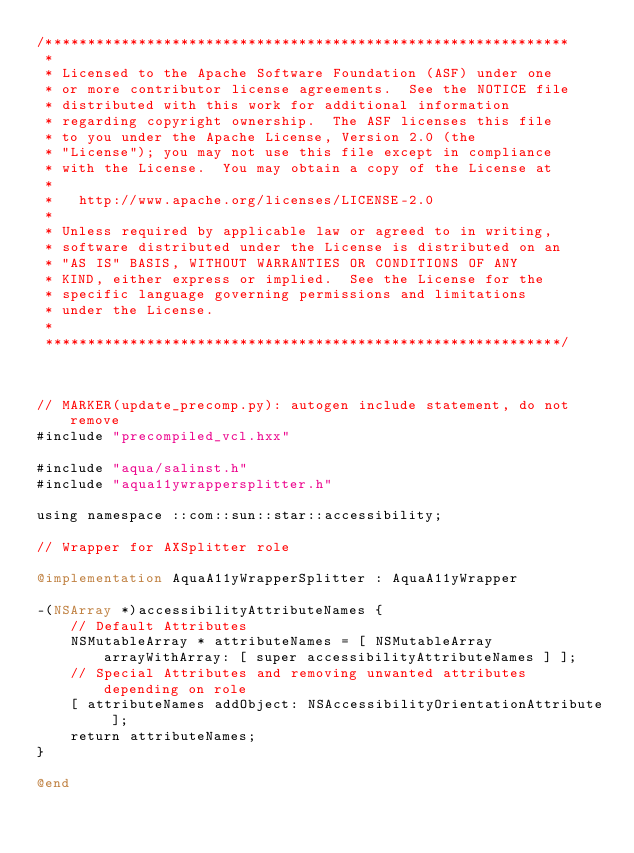<code> <loc_0><loc_0><loc_500><loc_500><_ObjectiveC_>/**************************************************************
 * 
 * Licensed to the Apache Software Foundation (ASF) under one
 * or more contributor license agreements.  See the NOTICE file
 * distributed with this work for additional information
 * regarding copyright ownership.  The ASF licenses this file
 * to you under the Apache License, Version 2.0 (the
 * "License"); you may not use this file except in compliance
 * with the License.  You may obtain a copy of the License at
 * 
 *   http://www.apache.org/licenses/LICENSE-2.0
 * 
 * Unless required by applicable law or agreed to in writing,
 * software distributed under the License is distributed on an
 * "AS IS" BASIS, WITHOUT WARRANTIES OR CONDITIONS OF ANY
 * KIND, either express or implied.  See the License for the
 * specific language governing permissions and limitations
 * under the License.
 * 
 *************************************************************/



// MARKER(update_precomp.py): autogen include statement, do not remove
#include "precompiled_vcl.hxx"

#include "aqua/salinst.h"
#include "aqua11ywrappersplitter.h"

using namespace ::com::sun::star::accessibility;

// Wrapper for AXSplitter role

@implementation AquaA11yWrapperSplitter : AquaA11yWrapper

-(NSArray *)accessibilityAttributeNames {
    // Default Attributes
    NSMutableArray * attributeNames = [ NSMutableArray arrayWithArray: [ super accessibilityAttributeNames ] ];
    // Special Attributes and removing unwanted attributes depending on role
    [ attributeNames addObject: NSAccessibilityOrientationAttribute ];
    return attributeNames;
}

@end
</code> 